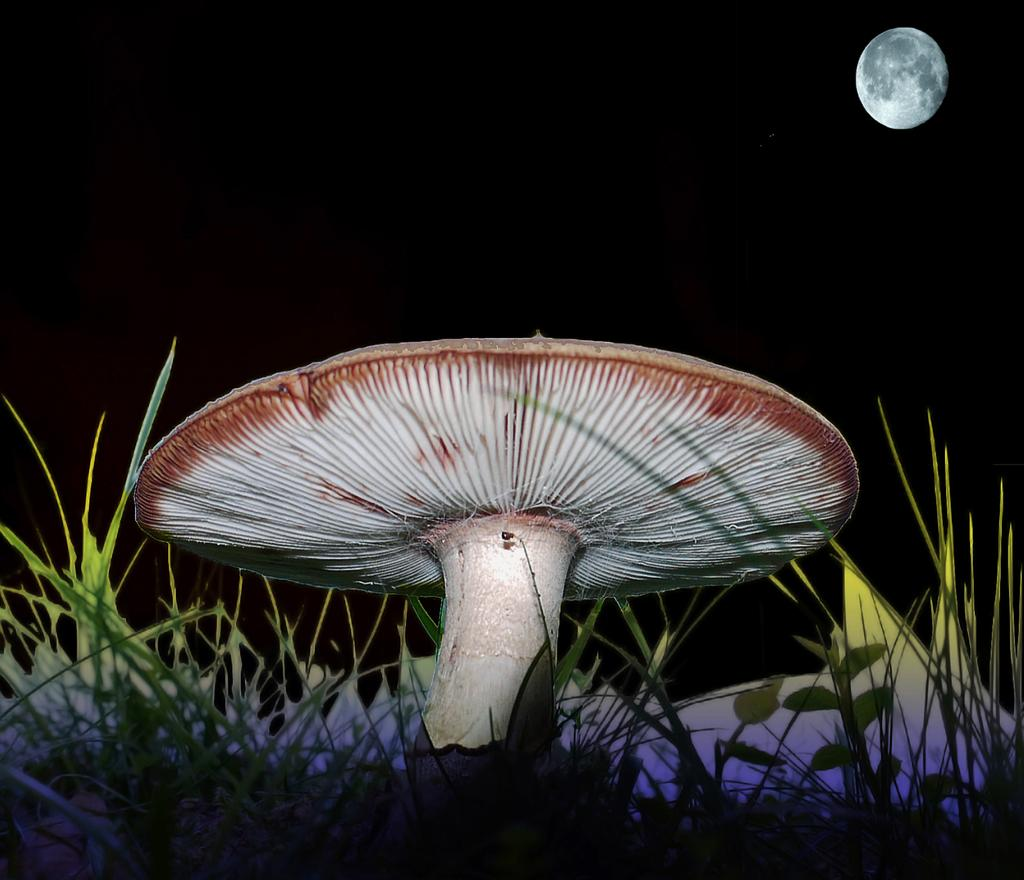What type of plant can be seen in the image? There is a mushroom in the image. What type of vegetation is present in the image? There is grass in the image. What celestial body is visible on the right side of the image? There is a moon visible on the right side of the image. How does the visitor interact with the thrill in the image? There is no visitor or thrill present in the image; it only features a mushroom, grass, and the moon. 